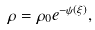<formula> <loc_0><loc_0><loc_500><loc_500>\rho = \rho _ { 0 } e ^ { - \psi ( \xi ) } ,</formula> 